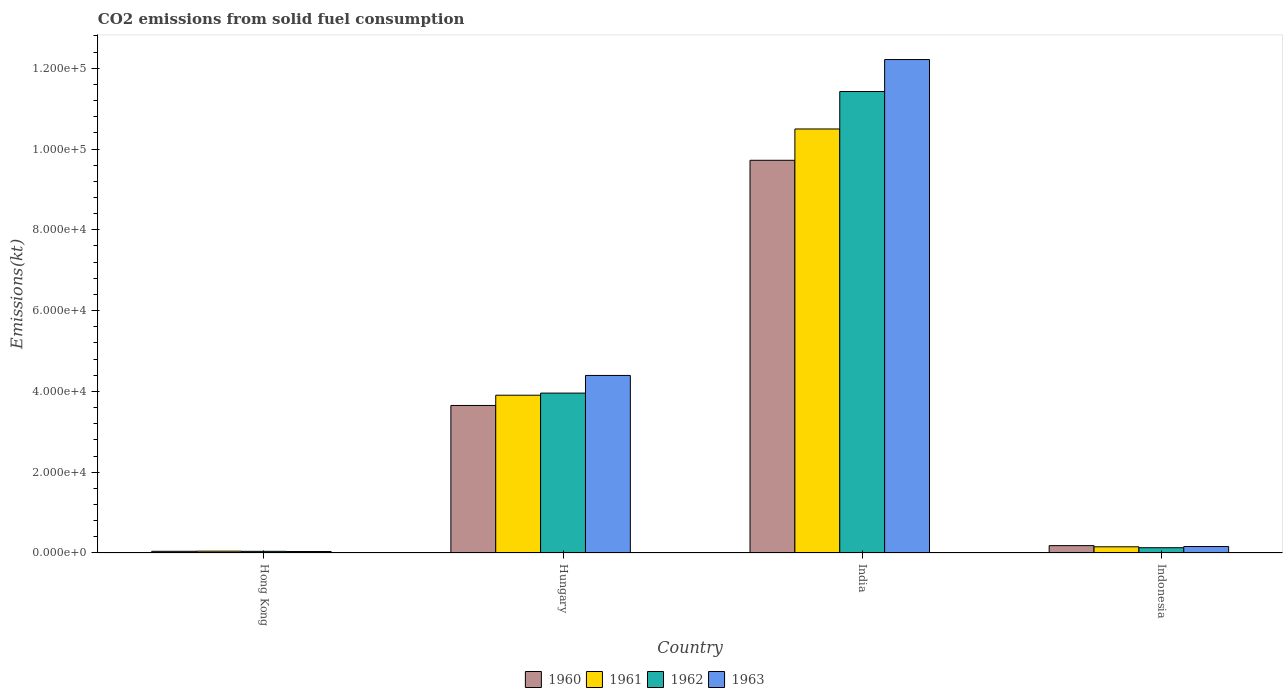Are the number of bars per tick equal to the number of legend labels?
Ensure brevity in your answer.  Yes. Are the number of bars on each tick of the X-axis equal?
Provide a short and direct response. Yes. How many bars are there on the 1st tick from the left?
Ensure brevity in your answer.  4. What is the label of the 2nd group of bars from the left?
Your answer should be compact. Hungary. In how many cases, is the number of bars for a given country not equal to the number of legend labels?
Your response must be concise. 0. What is the amount of CO2 emitted in 1960 in Hong Kong?
Offer a very short reply. 418.04. Across all countries, what is the maximum amount of CO2 emitted in 1961?
Offer a very short reply. 1.05e+05. Across all countries, what is the minimum amount of CO2 emitted in 1963?
Give a very brief answer. 359.37. In which country was the amount of CO2 emitted in 1960 minimum?
Provide a succinct answer. Hong Kong. What is the total amount of CO2 emitted in 1963 in the graph?
Provide a succinct answer. 1.68e+05. What is the difference between the amount of CO2 emitted in 1961 in Hungary and that in India?
Your answer should be very brief. -6.59e+04. What is the difference between the amount of CO2 emitted in 1963 in Hungary and the amount of CO2 emitted in 1960 in Hong Kong?
Provide a succinct answer. 4.35e+04. What is the average amount of CO2 emitted in 1963 per country?
Your response must be concise. 4.20e+04. What is the difference between the amount of CO2 emitted of/in 1960 and amount of CO2 emitted of/in 1962 in Hong Kong?
Make the answer very short. 7.33. What is the ratio of the amount of CO2 emitted in 1963 in Hong Kong to that in Hungary?
Your response must be concise. 0.01. Is the difference between the amount of CO2 emitted in 1960 in Hungary and Indonesia greater than the difference between the amount of CO2 emitted in 1962 in Hungary and Indonesia?
Offer a terse response. No. What is the difference between the highest and the second highest amount of CO2 emitted in 1963?
Provide a succinct answer. 1.21e+05. What is the difference between the highest and the lowest amount of CO2 emitted in 1963?
Make the answer very short. 1.22e+05. In how many countries, is the amount of CO2 emitted in 1962 greater than the average amount of CO2 emitted in 1962 taken over all countries?
Give a very brief answer. 2. Is the sum of the amount of CO2 emitted in 1962 in Hong Kong and Indonesia greater than the maximum amount of CO2 emitted in 1960 across all countries?
Make the answer very short. No. What does the 4th bar from the left in Hungary represents?
Provide a succinct answer. 1963. Are all the bars in the graph horizontal?
Provide a short and direct response. No. How many countries are there in the graph?
Your answer should be compact. 4. Are the values on the major ticks of Y-axis written in scientific E-notation?
Offer a terse response. Yes. Does the graph contain grids?
Ensure brevity in your answer.  No. Where does the legend appear in the graph?
Provide a succinct answer. Bottom center. How many legend labels are there?
Offer a very short reply. 4. How are the legend labels stacked?
Offer a terse response. Horizontal. What is the title of the graph?
Give a very brief answer. CO2 emissions from solid fuel consumption. Does "1975" appear as one of the legend labels in the graph?
Your response must be concise. No. What is the label or title of the X-axis?
Offer a terse response. Country. What is the label or title of the Y-axis?
Give a very brief answer. Emissions(kt). What is the Emissions(kt) of 1960 in Hong Kong?
Your response must be concise. 418.04. What is the Emissions(kt) in 1961 in Hong Kong?
Your response must be concise. 451.04. What is the Emissions(kt) of 1962 in Hong Kong?
Offer a very short reply. 410.7. What is the Emissions(kt) of 1963 in Hong Kong?
Your answer should be compact. 359.37. What is the Emissions(kt) in 1960 in Hungary?
Provide a succinct answer. 3.65e+04. What is the Emissions(kt) in 1961 in Hungary?
Provide a short and direct response. 3.91e+04. What is the Emissions(kt) in 1962 in Hungary?
Offer a terse response. 3.96e+04. What is the Emissions(kt) of 1963 in Hungary?
Provide a short and direct response. 4.39e+04. What is the Emissions(kt) of 1960 in India?
Give a very brief answer. 9.72e+04. What is the Emissions(kt) in 1961 in India?
Offer a very short reply. 1.05e+05. What is the Emissions(kt) in 1962 in India?
Give a very brief answer. 1.14e+05. What is the Emissions(kt) in 1963 in India?
Ensure brevity in your answer.  1.22e+05. What is the Emissions(kt) in 1960 in Indonesia?
Offer a terse response. 1822.5. What is the Emissions(kt) in 1961 in Indonesia?
Provide a short and direct response. 1529.14. What is the Emissions(kt) of 1962 in Indonesia?
Offer a very short reply. 1301.79. What is the Emissions(kt) in 1963 in Indonesia?
Your answer should be compact. 1595.14. Across all countries, what is the maximum Emissions(kt) of 1960?
Ensure brevity in your answer.  9.72e+04. Across all countries, what is the maximum Emissions(kt) in 1961?
Offer a terse response. 1.05e+05. Across all countries, what is the maximum Emissions(kt) in 1962?
Your answer should be compact. 1.14e+05. Across all countries, what is the maximum Emissions(kt) of 1963?
Make the answer very short. 1.22e+05. Across all countries, what is the minimum Emissions(kt) in 1960?
Offer a terse response. 418.04. Across all countries, what is the minimum Emissions(kt) of 1961?
Give a very brief answer. 451.04. Across all countries, what is the minimum Emissions(kt) in 1962?
Make the answer very short. 410.7. Across all countries, what is the minimum Emissions(kt) in 1963?
Offer a very short reply. 359.37. What is the total Emissions(kt) of 1960 in the graph?
Your answer should be very brief. 1.36e+05. What is the total Emissions(kt) of 1961 in the graph?
Provide a succinct answer. 1.46e+05. What is the total Emissions(kt) in 1962 in the graph?
Provide a short and direct response. 1.56e+05. What is the total Emissions(kt) of 1963 in the graph?
Offer a very short reply. 1.68e+05. What is the difference between the Emissions(kt) in 1960 in Hong Kong and that in Hungary?
Give a very brief answer. -3.61e+04. What is the difference between the Emissions(kt) in 1961 in Hong Kong and that in Hungary?
Provide a short and direct response. -3.86e+04. What is the difference between the Emissions(kt) of 1962 in Hong Kong and that in Hungary?
Provide a succinct answer. -3.92e+04. What is the difference between the Emissions(kt) of 1963 in Hong Kong and that in Hungary?
Your answer should be very brief. -4.36e+04. What is the difference between the Emissions(kt) in 1960 in Hong Kong and that in India?
Your response must be concise. -9.68e+04. What is the difference between the Emissions(kt) of 1961 in Hong Kong and that in India?
Offer a terse response. -1.05e+05. What is the difference between the Emissions(kt) of 1962 in Hong Kong and that in India?
Provide a succinct answer. -1.14e+05. What is the difference between the Emissions(kt) in 1963 in Hong Kong and that in India?
Provide a succinct answer. -1.22e+05. What is the difference between the Emissions(kt) of 1960 in Hong Kong and that in Indonesia?
Offer a terse response. -1404.46. What is the difference between the Emissions(kt) in 1961 in Hong Kong and that in Indonesia?
Provide a succinct answer. -1078.1. What is the difference between the Emissions(kt) in 1962 in Hong Kong and that in Indonesia?
Your answer should be very brief. -891.08. What is the difference between the Emissions(kt) of 1963 in Hong Kong and that in Indonesia?
Provide a succinct answer. -1235.78. What is the difference between the Emissions(kt) of 1960 in Hungary and that in India?
Make the answer very short. -6.07e+04. What is the difference between the Emissions(kt) of 1961 in Hungary and that in India?
Your answer should be compact. -6.59e+04. What is the difference between the Emissions(kt) of 1962 in Hungary and that in India?
Provide a short and direct response. -7.46e+04. What is the difference between the Emissions(kt) in 1963 in Hungary and that in India?
Provide a short and direct response. -7.82e+04. What is the difference between the Emissions(kt) in 1960 in Hungary and that in Indonesia?
Offer a very short reply. 3.47e+04. What is the difference between the Emissions(kt) in 1961 in Hungary and that in Indonesia?
Your answer should be very brief. 3.75e+04. What is the difference between the Emissions(kt) of 1962 in Hungary and that in Indonesia?
Your response must be concise. 3.83e+04. What is the difference between the Emissions(kt) of 1963 in Hungary and that in Indonesia?
Your response must be concise. 4.24e+04. What is the difference between the Emissions(kt) in 1960 in India and that in Indonesia?
Your response must be concise. 9.54e+04. What is the difference between the Emissions(kt) of 1961 in India and that in Indonesia?
Provide a succinct answer. 1.03e+05. What is the difference between the Emissions(kt) in 1962 in India and that in Indonesia?
Give a very brief answer. 1.13e+05. What is the difference between the Emissions(kt) of 1963 in India and that in Indonesia?
Offer a terse response. 1.21e+05. What is the difference between the Emissions(kt) of 1960 in Hong Kong and the Emissions(kt) of 1961 in Hungary?
Your response must be concise. -3.86e+04. What is the difference between the Emissions(kt) in 1960 in Hong Kong and the Emissions(kt) in 1962 in Hungary?
Your answer should be very brief. -3.92e+04. What is the difference between the Emissions(kt) of 1960 in Hong Kong and the Emissions(kt) of 1963 in Hungary?
Keep it short and to the point. -4.35e+04. What is the difference between the Emissions(kt) in 1961 in Hong Kong and the Emissions(kt) in 1962 in Hungary?
Your answer should be very brief. -3.91e+04. What is the difference between the Emissions(kt) in 1961 in Hong Kong and the Emissions(kt) in 1963 in Hungary?
Offer a terse response. -4.35e+04. What is the difference between the Emissions(kt) of 1962 in Hong Kong and the Emissions(kt) of 1963 in Hungary?
Offer a very short reply. -4.35e+04. What is the difference between the Emissions(kt) of 1960 in Hong Kong and the Emissions(kt) of 1961 in India?
Your answer should be very brief. -1.05e+05. What is the difference between the Emissions(kt) in 1960 in Hong Kong and the Emissions(kt) in 1962 in India?
Provide a succinct answer. -1.14e+05. What is the difference between the Emissions(kt) in 1960 in Hong Kong and the Emissions(kt) in 1963 in India?
Your answer should be compact. -1.22e+05. What is the difference between the Emissions(kt) in 1961 in Hong Kong and the Emissions(kt) in 1962 in India?
Keep it short and to the point. -1.14e+05. What is the difference between the Emissions(kt) in 1961 in Hong Kong and the Emissions(kt) in 1963 in India?
Ensure brevity in your answer.  -1.22e+05. What is the difference between the Emissions(kt) in 1962 in Hong Kong and the Emissions(kt) in 1963 in India?
Your answer should be very brief. -1.22e+05. What is the difference between the Emissions(kt) of 1960 in Hong Kong and the Emissions(kt) of 1961 in Indonesia?
Provide a succinct answer. -1111.1. What is the difference between the Emissions(kt) in 1960 in Hong Kong and the Emissions(kt) in 1962 in Indonesia?
Give a very brief answer. -883.75. What is the difference between the Emissions(kt) of 1960 in Hong Kong and the Emissions(kt) of 1963 in Indonesia?
Keep it short and to the point. -1177.11. What is the difference between the Emissions(kt) of 1961 in Hong Kong and the Emissions(kt) of 1962 in Indonesia?
Your response must be concise. -850.74. What is the difference between the Emissions(kt) in 1961 in Hong Kong and the Emissions(kt) in 1963 in Indonesia?
Your response must be concise. -1144.1. What is the difference between the Emissions(kt) in 1962 in Hong Kong and the Emissions(kt) in 1963 in Indonesia?
Offer a terse response. -1184.44. What is the difference between the Emissions(kt) in 1960 in Hungary and the Emissions(kt) in 1961 in India?
Provide a succinct answer. -6.84e+04. What is the difference between the Emissions(kt) in 1960 in Hungary and the Emissions(kt) in 1962 in India?
Offer a terse response. -7.77e+04. What is the difference between the Emissions(kt) in 1960 in Hungary and the Emissions(kt) in 1963 in India?
Ensure brevity in your answer.  -8.56e+04. What is the difference between the Emissions(kt) in 1961 in Hungary and the Emissions(kt) in 1962 in India?
Provide a short and direct response. -7.52e+04. What is the difference between the Emissions(kt) of 1961 in Hungary and the Emissions(kt) of 1963 in India?
Give a very brief answer. -8.31e+04. What is the difference between the Emissions(kt) of 1962 in Hungary and the Emissions(kt) of 1963 in India?
Your answer should be compact. -8.26e+04. What is the difference between the Emissions(kt) of 1960 in Hungary and the Emissions(kt) of 1961 in Indonesia?
Keep it short and to the point. 3.50e+04. What is the difference between the Emissions(kt) in 1960 in Hungary and the Emissions(kt) in 1962 in Indonesia?
Make the answer very short. 3.52e+04. What is the difference between the Emissions(kt) in 1960 in Hungary and the Emissions(kt) in 1963 in Indonesia?
Your answer should be very brief. 3.49e+04. What is the difference between the Emissions(kt) of 1961 in Hungary and the Emissions(kt) of 1962 in Indonesia?
Offer a terse response. 3.78e+04. What is the difference between the Emissions(kt) in 1961 in Hungary and the Emissions(kt) in 1963 in Indonesia?
Your response must be concise. 3.75e+04. What is the difference between the Emissions(kt) of 1962 in Hungary and the Emissions(kt) of 1963 in Indonesia?
Provide a short and direct response. 3.80e+04. What is the difference between the Emissions(kt) in 1960 in India and the Emissions(kt) in 1961 in Indonesia?
Your response must be concise. 9.57e+04. What is the difference between the Emissions(kt) in 1960 in India and the Emissions(kt) in 1962 in Indonesia?
Offer a very short reply. 9.59e+04. What is the difference between the Emissions(kt) in 1960 in India and the Emissions(kt) in 1963 in Indonesia?
Offer a very short reply. 9.56e+04. What is the difference between the Emissions(kt) in 1961 in India and the Emissions(kt) in 1962 in Indonesia?
Offer a terse response. 1.04e+05. What is the difference between the Emissions(kt) of 1961 in India and the Emissions(kt) of 1963 in Indonesia?
Your answer should be very brief. 1.03e+05. What is the difference between the Emissions(kt) of 1962 in India and the Emissions(kt) of 1963 in Indonesia?
Provide a succinct answer. 1.13e+05. What is the average Emissions(kt) in 1960 per country?
Your answer should be very brief. 3.40e+04. What is the average Emissions(kt) of 1961 per country?
Provide a short and direct response. 3.65e+04. What is the average Emissions(kt) of 1962 per country?
Make the answer very short. 3.89e+04. What is the average Emissions(kt) of 1963 per country?
Your response must be concise. 4.20e+04. What is the difference between the Emissions(kt) in 1960 and Emissions(kt) in 1961 in Hong Kong?
Your response must be concise. -33. What is the difference between the Emissions(kt) of 1960 and Emissions(kt) of 1962 in Hong Kong?
Make the answer very short. 7.33. What is the difference between the Emissions(kt) in 1960 and Emissions(kt) in 1963 in Hong Kong?
Ensure brevity in your answer.  58.67. What is the difference between the Emissions(kt) of 1961 and Emissions(kt) of 1962 in Hong Kong?
Offer a terse response. 40.34. What is the difference between the Emissions(kt) in 1961 and Emissions(kt) in 1963 in Hong Kong?
Keep it short and to the point. 91.67. What is the difference between the Emissions(kt) of 1962 and Emissions(kt) of 1963 in Hong Kong?
Ensure brevity in your answer.  51.34. What is the difference between the Emissions(kt) of 1960 and Emissions(kt) of 1961 in Hungary?
Ensure brevity in your answer.  -2537.56. What is the difference between the Emissions(kt) in 1960 and Emissions(kt) in 1962 in Hungary?
Offer a terse response. -3058.28. What is the difference between the Emissions(kt) in 1960 and Emissions(kt) in 1963 in Hungary?
Provide a succinct answer. -7429.34. What is the difference between the Emissions(kt) of 1961 and Emissions(kt) of 1962 in Hungary?
Keep it short and to the point. -520.71. What is the difference between the Emissions(kt) of 1961 and Emissions(kt) of 1963 in Hungary?
Your response must be concise. -4891.78. What is the difference between the Emissions(kt) in 1962 and Emissions(kt) in 1963 in Hungary?
Give a very brief answer. -4371.06. What is the difference between the Emissions(kt) in 1960 and Emissions(kt) in 1961 in India?
Keep it short and to the point. -7748.37. What is the difference between the Emissions(kt) in 1960 and Emissions(kt) in 1962 in India?
Provide a short and direct response. -1.70e+04. What is the difference between the Emissions(kt) in 1960 and Emissions(kt) in 1963 in India?
Make the answer very short. -2.49e+04. What is the difference between the Emissions(kt) of 1961 and Emissions(kt) of 1962 in India?
Give a very brief answer. -9270.18. What is the difference between the Emissions(kt) in 1961 and Emissions(kt) in 1963 in India?
Give a very brief answer. -1.72e+04. What is the difference between the Emissions(kt) in 1962 and Emissions(kt) in 1963 in India?
Give a very brief answer. -7917.05. What is the difference between the Emissions(kt) in 1960 and Emissions(kt) in 1961 in Indonesia?
Offer a very short reply. 293.36. What is the difference between the Emissions(kt) of 1960 and Emissions(kt) of 1962 in Indonesia?
Provide a succinct answer. 520.71. What is the difference between the Emissions(kt) of 1960 and Emissions(kt) of 1963 in Indonesia?
Make the answer very short. 227.35. What is the difference between the Emissions(kt) in 1961 and Emissions(kt) in 1962 in Indonesia?
Provide a short and direct response. 227.35. What is the difference between the Emissions(kt) in 1961 and Emissions(kt) in 1963 in Indonesia?
Make the answer very short. -66.01. What is the difference between the Emissions(kt) of 1962 and Emissions(kt) of 1963 in Indonesia?
Offer a terse response. -293.36. What is the ratio of the Emissions(kt) of 1960 in Hong Kong to that in Hungary?
Your response must be concise. 0.01. What is the ratio of the Emissions(kt) in 1961 in Hong Kong to that in Hungary?
Your answer should be compact. 0.01. What is the ratio of the Emissions(kt) of 1962 in Hong Kong to that in Hungary?
Keep it short and to the point. 0.01. What is the ratio of the Emissions(kt) in 1963 in Hong Kong to that in Hungary?
Your answer should be compact. 0.01. What is the ratio of the Emissions(kt) of 1960 in Hong Kong to that in India?
Keep it short and to the point. 0. What is the ratio of the Emissions(kt) of 1961 in Hong Kong to that in India?
Give a very brief answer. 0. What is the ratio of the Emissions(kt) in 1962 in Hong Kong to that in India?
Your answer should be very brief. 0. What is the ratio of the Emissions(kt) of 1963 in Hong Kong to that in India?
Offer a very short reply. 0. What is the ratio of the Emissions(kt) in 1960 in Hong Kong to that in Indonesia?
Your answer should be compact. 0.23. What is the ratio of the Emissions(kt) of 1961 in Hong Kong to that in Indonesia?
Make the answer very short. 0.29. What is the ratio of the Emissions(kt) in 1962 in Hong Kong to that in Indonesia?
Your answer should be very brief. 0.32. What is the ratio of the Emissions(kt) in 1963 in Hong Kong to that in Indonesia?
Offer a terse response. 0.23. What is the ratio of the Emissions(kt) of 1960 in Hungary to that in India?
Ensure brevity in your answer.  0.38. What is the ratio of the Emissions(kt) of 1961 in Hungary to that in India?
Offer a very short reply. 0.37. What is the ratio of the Emissions(kt) of 1962 in Hungary to that in India?
Your answer should be compact. 0.35. What is the ratio of the Emissions(kt) in 1963 in Hungary to that in India?
Your response must be concise. 0.36. What is the ratio of the Emissions(kt) of 1960 in Hungary to that in Indonesia?
Provide a succinct answer. 20.04. What is the ratio of the Emissions(kt) of 1961 in Hungary to that in Indonesia?
Offer a terse response. 25.54. What is the ratio of the Emissions(kt) of 1962 in Hungary to that in Indonesia?
Offer a terse response. 30.4. What is the ratio of the Emissions(kt) in 1963 in Hungary to that in Indonesia?
Offer a very short reply. 27.55. What is the ratio of the Emissions(kt) of 1960 in India to that in Indonesia?
Offer a very short reply. 53.34. What is the ratio of the Emissions(kt) of 1961 in India to that in Indonesia?
Provide a short and direct response. 68.64. What is the ratio of the Emissions(kt) in 1962 in India to that in Indonesia?
Your answer should be very brief. 87.75. What is the ratio of the Emissions(kt) in 1963 in India to that in Indonesia?
Your response must be concise. 76.57. What is the difference between the highest and the second highest Emissions(kt) of 1960?
Your response must be concise. 6.07e+04. What is the difference between the highest and the second highest Emissions(kt) in 1961?
Keep it short and to the point. 6.59e+04. What is the difference between the highest and the second highest Emissions(kt) in 1962?
Your answer should be very brief. 7.46e+04. What is the difference between the highest and the second highest Emissions(kt) in 1963?
Ensure brevity in your answer.  7.82e+04. What is the difference between the highest and the lowest Emissions(kt) in 1960?
Provide a short and direct response. 9.68e+04. What is the difference between the highest and the lowest Emissions(kt) in 1961?
Provide a succinct answer. 1.05e+05. What is the difference between the highest and the lowest Emissions(kt) of 1962?
Provide a succinct answer. 1.14e+05. What is the difference between the highest and the lowest Emissions(kt) of 1963?
Give a very brief answer. 1.22e+05. 